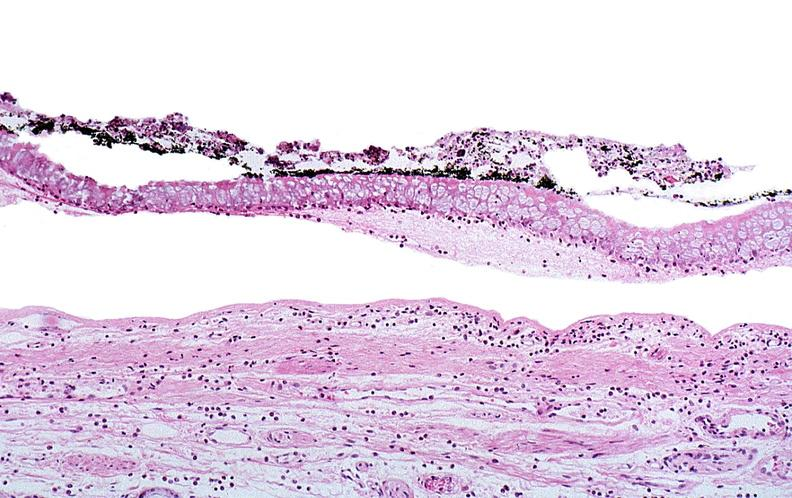where is this?
Answer the question using a single word or phrase. Skin 